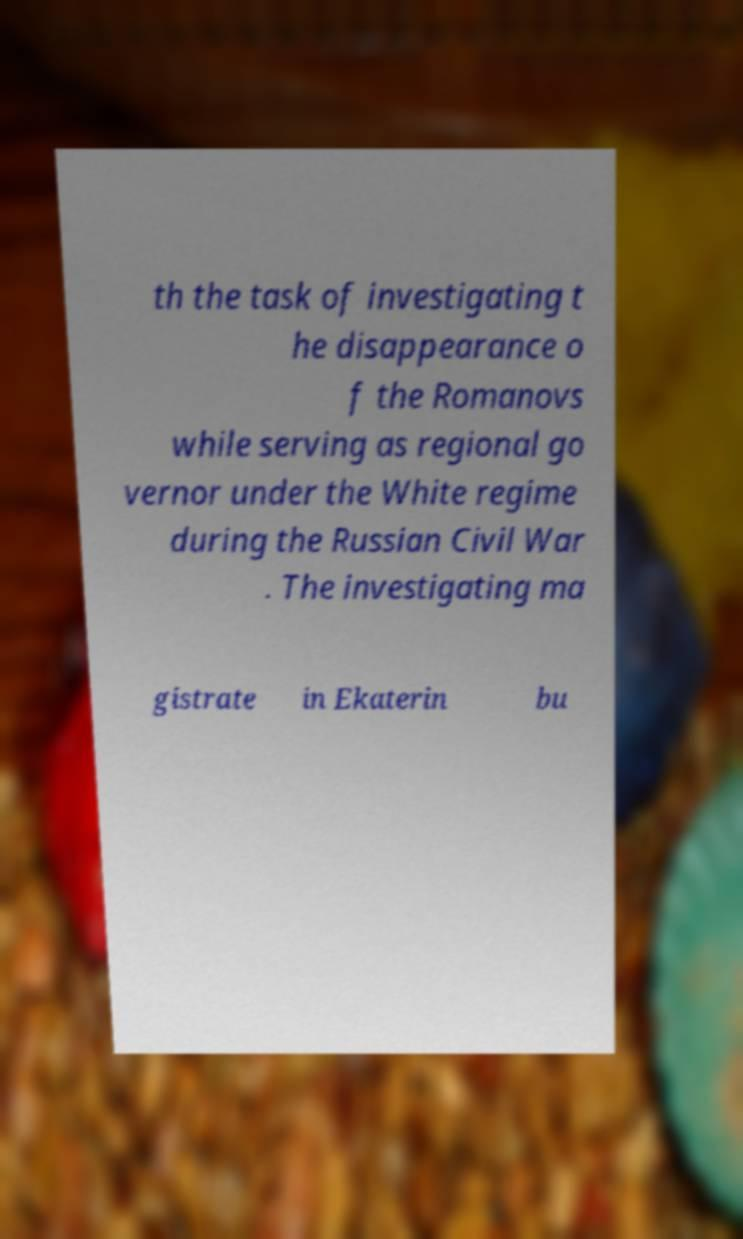Please read and relay the text visible in this image. What does it say? th the task of investigating t he disappearance o f the Romanovs while serving as regional go vernor under the White regime during the Russian Civil War . The investigating ma gistrate in Ekaterin bu 